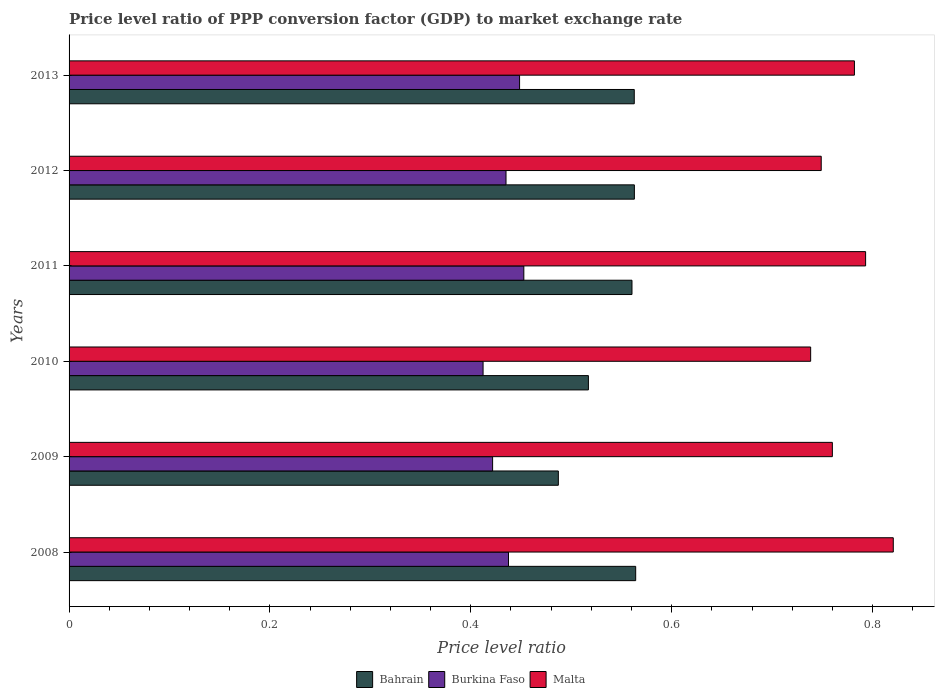How many groups of bars are there?
Ensure brevity in your answer.  6. Are the number of bars per tick equal to the number of legend labels?
Make the answer very short. Yes. What is the label of the 4th group of bars from the top?
Give a very brief answer. 2010. In how many cases, is the number of bars for a given year not equal to the number of legend labels?
Keep it short and to the point. 0. What is the price level ratio in Burkina Faso in 2012?
Your answer should be very brief. 0.44. Across all years, what is the maximum price level ratio in Bahrain?
Offer a very short reply. 0.56. Across all years, what is the minimum price level ratio in Bahrain?
Ensure brevity in your answer.  0.49. In which year was the price level ratio in Malta maximum?
Your response must be concise. 2008. In which year was the price level ratio in Bahrain minimum?
Make the answer very short. 2009. What is the total price level ratio in Malta in the graph?
Offer a very short reply. 4.64. What is the difference between the price level ratio in Bahrain in 2008 and that in 2009?
Offer a terse response. 0.08. What is the difference between the price level ratio in Malta in 2010 and the price level ratio in Burkina Faso in 2013?
Your answer should be compact. 0.29. What is the average price level ratio in Malta per year?
Give a very brief answer. 0.77. In the year 2010, what is the difference between the price level ratio in Malta and price level ratio in Bahrain?
Provide a succinct answer. 0.22. What is the ratio of the price level ratio in Bahrain in 2008 to that in 2010?
Offer a terse response. 1.09. Is the difference between the price level ratio in Malta in 2009 and 2012 greater than the difference between the price level ratio in Bahrain in 2009 and 2012?
Ensure brevity in your answer.  Yes. What is the difference between the highest and the second highest price level ratio in Malta?
Give a very brief answer. 0.03. What is the difference between the highest and the lowest price level ratio in Malta?
Offer a very short reply. 0.08. In how many years, is the price level ratio in Burkina Faso greater than the average price level ratio in Burkina Faso taken over all years?
Your answer should be very brief. 4. Is the sum of the price level ratio in Malta in 2008 and 2013 greater than the maximum price level ratio in Burkina Faso across all years?
Offer a terse response. Yes. What does the 3rd bar from the top in 2008 represents?
Offer a very short reply. Bahrain. What does the 2nd bar from the bottom in 2008 represents?
Provide a succinct answer. Burkina Faso. Are the values on the major ticks of X-axis written in scientific E-notation?
Offer a terse response. No. Where does the legend appear in the graph?
Provide a succinct answer. Bottom center. How are the legend labels stacked?
Ensure brevity in your answer.  Horizontal. What is the title of the graph?
Your response must be concise. Price level ratio of PPP conversion factor (GDP) to market exchange rate. What is the label or title of the X-axis?
Offer a very short reply. Price level ratio. What is the Price level ratio of Bahrain in 2008?
Your response must be concise. 0.56. What is the Price level ratio of Burkina Faso in 2008?
Keep it short and to the point. 0.44. What is the Price level ratio of Malta in 2008?
Your response must be concise. 0.82. What is the Price level ratio in Bahrain in 2009?
Offer a terse response. 0.49. What is the Price level ratio in Burkina Faso in 2009?
Give a very brief answer. 0.42. What is the Price level ratio in Malta in 2009?
Your answer should be very brief. 0.76. What is the Price level ratio in Bahrain in 2010?
Give a very brief answer. 0.52. What is the Price level ratio of Burkina Faso in 2010?
Make the answer very short. 0.41. What is the Price level ratio in Malta in 2010?
Keep it short and to the point. 0.74. What is the Price level ratio of Bahrain in 2011?
Your answer should be compact. 0.56. What is the Price level ratio in Burkina Faso in 2011?
Your response must be concise. 0.45. What is the Price level ratio of Malta in 2011?
Give a very brief answer. 0.79. What is the Price level ratio of Bahrain in 2012?
Offer a terse response. 0.56. What is the Price level ratio in Burkina Faso in 2012?
Offer a terse response. 0.44. What is the Price level ratio of Malta in 2012?
Provide a succinct answer. 0.75. What is the Price level ratio in Bahrain in 2013?
Your answer should be compact. 0.56. What is the Price level ratio of Burkina Faso in 2013?
Give a very brief answer. 0.45. What is the Price level ratio of Malta in 2013?
Your response must be concise. 0.78. Across all years, what is the maximum Price level ratio in Bahrain?
Your answer should be compact. 0.56. Across all years, what is the maximum Price level ratio of Burkina Faso?
Provide a succinct answer. 0.45. Across all years, what is the maximum Price level ratio of Malta?
Your response must be concise. 0.82. Across all years, what is the minimum Price level ratio of Bahrain?
Your answer should be very brief. 0.49. Across all years, what is the minimum Price level ratio of Burkina Faso?
Offer a terse response. 0.41. Across all years, what is the minimum Price level ratio of Malta?
Provide a succinct answer. 0.74. What is the total Price level ratio of Bahrain in the graph?
Your answer should be very brief. 3.25. What is the total Price level ratio of Burkina Faso in the graph?
Give a very brief answer. 2.61. What is the total Price level ratio of Malta in the graph?
Provide a short and direct response. 4.64. What is the difference between the Price level ratio in Bahrain in 2008 and that in 2009?
Your answer should be compact. 0.08. What is the difference between the Price level ratio of Burkina Faso in 2008 and that in 2009?
Your response must be concise. 0.02. What is the difference between the Price level ratio of Malta in 2008 and that in 2009?
Give a very brief answer. 0.06. What is the difference between the Price level ratio in Bahrain in 2008 and that in 2010?
Offer a terse response. 0.05. What is the difference between the Price level ratio of Burkina Faso in 2008 and that in 2010?
Offer a very short reply. 0.03. What is the difference between the Price level ratio of Malta in 2008 and that in 2010?
Give a very brief answer. 0.08. What is the difference between the Price level ratio in Bahrain in 2008 and that in 2011?
Ensure brevity in your answer.  0. What is the difference between the Price level ratio in Burkina Faso in 2008 and that in 2011?
Provide a short and direct response. -0.02. What is the difference between the Price level ratio of Malta in 2008 and that in 2011?
Provide a short and direct response. 0.03. What is the difference between the Price level ratio in Bahrain in 2008 and that in 2012?
Provide a succinct answer. 0. What is the difference between the Price level ratio in Burkina Faso in 2008 and that in 2012?
Your answer should be very brief. 0. What is the difference between the Price level ratio of Malta in 2008 and that in 2012?
Keep it short and to the point. 0.07. What is the difference between the Price level ratio of Bahrain in 2008 and that in 2013?
Provide a succinct answer. 0. What is the difference between the Price level ratio of Burkina Faso in 2008 and that in 2013?
Your answer should be compact. -0.01. What is the difference between the Price level ratio in Malta in 2008 and that in 2013?
Provide a succinct answer. 0.04. What is the difference between the Price level ratio of Bahrain in 2009 and that in 2010?
Your answer should be compact. -0.03. What is the difference between the Price level ratio of Burkina Faso in 2009 and that in 2010?
Provide a short and direct response. 0.01. What is the difference between the Price level ratio of Malta in 2009 and that in 2010?
Ensure brevity in your answer.  0.02. What is the difference between the Price level ratio of Bahrain in 2009 and that in 2011?
Provide a short and direct response. -0.07. What is the difference between the Price level ratio in Burkina Faso in 2009 and that in 2011?
Offer a very short reply. -0.03. What is the difference between the Price level ratio in Malta in 2009 and that in 2011?
Provide a succinct answer. -0.03. What is the difference between the Price level ratio in Bahrain in 2009 and that in 2012?
Give a very brief answer. -0.08. What is the difference between the Price level ratio of Burkina Faso in 2009 and that in 2012?
Your answer should be compact. -0.01. What is the difference between the Price level ratio of Malta in 2009 and that in 2012?
Your answer should be compact. 0.01. What is the difference between the Price level ratio in Bahrain in 2009 and that in 2013?
Provide a short and direct response. -0.08. What is the difference between the Price level ratio in Burkina Faso in 2009 and that in 2013?
Your response must be concise. -0.03. What is the difference between the Price level ratio of Malta in 2009 and that in 2013?
Your answer should be compact. -0.02. What is the difference between the Price level ratio of Bahrain in 2010 and that in 2011?
Give a very brief answer. -0.04. What is the difference between the Price level ratio of Burkina Faso in 2010 and that in 2011?
Make the answer very short. -0.04. What is the difference between the Price level ratio in Malta in 2010 and that in 2011?
Keep it short and to the point. -0.05. What is the difference between the Price level ratio of Bahrain in 2010 and that in 2012?
Offer a very short reply. -0.05. What is the difference between the Price level ratio of Burkina Faso in 2010 and that in 2012?
Your response must be concise. -0.02. What is the difference between the Price level ratio in Malta in 2010 and that in 2012?
Make the answer very short. -0.01. What is the difference between the Price level ratio in Bahrain in 2010 and that in 2013?
Ensure brevity in your answer.  -0.05. What is the difference between the Price level ratio of Burkina Faso in 2010 and that in 2013?
Offer a terse response. -0.04. What is the difference between the Price level ratio of Malta in 2010 and that in 2013?
Give a very brief answer. -0.04. What is the difference between the Price level ratio of Bahrain in 2011 and that in 2012?
Provide a short and direct response. -0. What is the difference between the Price level ratio of Burkina Faso in 2011 and that in 2012?
Provide a short and direct response. 0.02. What is the difference between the Price level ratio of Malta in 2011 and that in 2012?
Give a very brief answer. 0.04. What is the difference between the Price level ratio in Bahrain in 2011 and that in 2013?
Your answer should be compact. -0. What is the difference between the Price level ratio of Burkina Faso in 2011 and that in 2013?
Your answer should be compact. 0. What is the difference between the Price level ratio in Malta in 2011 and that in 2013?
Offer a terse response. 0.01. What is the difference between the Price level ratio in Bahrain in 2012 and that in 2013?
Your answer should be very brief. 0. What is the difference between the Price level ratio in Burkina Faso in 2012 and that in 2013?
Provide a short and direct response. -0.01. What is the difference between the Price level ratio of Malta in 2012 and that in 2013?
Ensure brevity in your answer.  -0.03. What is the difference between the Price level ratio of Bahrain in 2008 and the Price level ratio of Burkina Faso in 2009?
Give a very brief answer. 0.14. What is the difference between the Price level ratio in Bahrain in 2008 and the Price level ratio in Malta in 2009?
Offer a very short reply. -0.2. What is the difference between the Price level ratio in Burkina Faso in 2008 and the Price level ratio in Malta in 2009?
Keep it short and to the point. -0.32. What is the difference between the Price level ratio of Bahrain in 2008 and the Price level ratio of Burkina Faso in 2010?
Provide a succinct answer. 0.15. What is the difference between the Price level ratio in Bahrain in 2008 and the Price level ratio in Malta in 2010?
Offer a very short reply. -0.17. What is the difference between the Price level ratio of Burkina Faso in 2008 and the Price level ratio of Malta in 2010?
Give a very brief answer. -0.3. What is the difference between the Price level ratio of Bahrain in 2008 and the Price level ratio of Burkina Faso in 2011?
Keep it short and to the point. 0.11. What is the difference between the Price level ratio in Bahrain in 2008 and the Price level ratio in Malta in 2011?
Ensure brevity in your answer.  -0.23. What is the difference between the Price level ratio in Burkina Faso in 2008 and the Price level ratio in Malta in 2011?
Ensure brevity in your answer.  -0.36. What is the difference between the Price level ratio of Bahrain in 2008 and the Price level ratio of Burkina Faso in 2012?
Provide a succinct answer. 0.13. What is the difference between the Price level ratio in Bahrain in 2008 and the Price level ratio in Malta in 2012?
Ensure brevity in your answer.  -0.18. What is the difference between the Price level ratio of Burkina Faso in 2008 and the Price level ratio of Malta in 2012?
Make the answer very short. -0.31. What is the difference between the Price level ratio in Bahrain in 2008 and the Price level ratio in Burkina Faso in 2013?
Keep it short and to the point. 0.12. What is the difference between the Price level ratio of Bahrain in 2008 and the Price level ratio of Malta in 2013?
Offer a terse response. -0.22. What is the difference between the Price level ratio in Burkina Faso in 2008 and the Price level ratio in Malta in 2013?
Your response must be concise. -0.34. What is the difference between the Price level ratio in Bahrain in 2009 and the Price level ratio in Burkina Faso in 2010?
Your answer should be very brief. 0.07. What is the difference between the Price level ratio in Bahrain in 2009 and the Price level ratio in Malta in 2010?
Ensure brevity in your answer.  -0.25. What is the difference between the Price level ratio in Burkina Faso in 2009 and the Price level ratio in Malta in 2010?
Offer a very short reply. -0.32. What is the difference between the Price level ratio in Bahrain in 2009 and the Price level ratio in Burkina Faso in 2011?
Provide a succinct answer. 0.03. What is the difference between the Price level ratio in Bahrain in 2009 and the Price level ratio in Malta in 2011?
Offer a terse response. -0.31. What is the difference between the Price level ratio in Burkina Faso in 2009 and the Price level ratio in Malta in 2011?
Provide a short and direct response. -0.37. What is the difference between the Price level ratio of Bahrain in 2009 and the Price level ratio of Burkina Faso in 2012?
Offer a very short reply. 0.05. What is the difference between the Price level ratio in Bahrain in 2009 and the Price level ratio in Malta in 2012?
Your answer should be very brief. -0.26. What is the difference between the Price level ratio in Burkina Faso in 2009 and the Price level ratio in Malta in 2012?
Give a very brief answer. -0.33. What is the difference between the Price level ratio in Bahrain in 2009 and the Price level ratio in Burkina Faso in 2013?
Your answer should be compact. 0.04. What is the difference between the Price level ratio of Bahrain in 2009 and the Price level ratio of Malta in 2013?
Provide a succinct answer. -0.29. What is the difference between the Price level ratio in Burkina Faso in 2009 and the Price level ratio in Malta in 2013?
Your response must be concise. -0.36. What is the difference between the Price level ratio in Bahrain in 2010 and the Price level ratio in Burkina Faso in 2011?
Your response must be concise. 0.06. What is the difference between the Price level ratio in Bahrain in 2010 and the Price level ratio in Malta in 2011?
Provide a succinct answer. -0.28. What is the difference between the Price level ratio in Burkina Faso in 2010 and the Price level ratio in Malta in 2011?
Ensure brevity in your answer.  -0.38. What is the difference between the Price level ratio in Bahrain in 2010 and the Price level ratio in Burkina Faso in 2012?
Provide a short and direct response. 0.08. What is the difference between the Price level ratio of Bahrain in 2010 and the Price level ratio of Malta in 2012?
Your answer should be very brief. -0.23. What is the difference between the Price level ratio of Burkina Faso in 2010 and the Price level ratio of Malta in 2012?
Offer a terse response. -0.34. What is the difference between the Price level ratio in Bahrain in 2010 and the Price level ratio in Burkina Faso in 2013?
Provide a short and direct response. 0.07. What is the difference between the Price level ratio of Bahrain in 2010 and the Price level ratio of Malta in 2013?
Keep it short and to the point. -0.26. What is the difference between the Price level ratio in Burkina Faso in 2010 and the Price level ratio in Malta in 2013?
Your answer should be compact. -0.37. What is the difference between the Price level ratio of Bahrain in 2011 and the Price level ratio of Burkina Faso in 2012?
Your answer should be compact. 0.13. What is the difference between the Price level ratio of Bahrain in 2011 and the Price level ratio of Malta in 2012?
Your response must be concise. -0.19. What is the difference between the Price level ratio in Burkina Faso in 2011 and the Price level ratio in Malta in 2012?
Make the answer very short. -0.3. What is the difference between the Price level ratio in Bahrain in 2011 and the Price level ratio in Burkina Faso in 2013?
Give a very brief answer. 0.11. What is the difference between the Price level ratio of Bahrain in 2011 and the Price level ratio of Malta in 2013?
Keep it short and to the point. -0.22. What is the difference between the Price level ratio in Burkina Faso in 2011 and the Price level ratio in Malta in 2013?
Offer a terse response. -0.33. What is the difference between the Price level ratio of Bahrain in 2012 and the Price level ratio of Burkina Faso in 2013?
Give a very brief answer. 0.11. What is the difference between the Price level ratio of Bahrain in 2012 and the Price level ratio of Malta in 2013?
Provide a succinct answer. -0.22. What is the difference between the Price level ratio in Burkina Faso in 2012 and the Price level ratio in Malta in 2013?
Offer a very short reply. -0.35. What is the average Price level ratio in Bahrain per year?
Your answer should be very brief. 0.54. What is the average Price level ratio of Burkina Faso per year?
Keep it short and to the point. 0.43. What is the average Price level ratio in Malta per year?
Your answer should be compact. 0.77. In the year 2008, what is the difference between the Price level ratio in Bahrain and Price level ratio in Burkina Faso?
Provide a short and direct response. 0.13. In the year 2008, what is the difference between the Price level ratio in Bahrain and Price level ratio in Malta?
Provide a short and direct response. -0.26. In the year 2008, what is the difference between the Price level ratio of Burkina Faso and Price level ratio of Malta?
Provide a short and direct response. -0.38. In the year 2009, what is the difference between the Price level ratio of Bahrain and Price level ratio of Burkina Faso?
Offer a terse response. 0.07. In the year 2009, what is the difference between the Price level ratio of Bahrain and Price level ratio of Malta?
Give a very brief answer. -0.27. In the year 2009, what is the difference between the Price level ratio in Burkina Faso and Price level ratio in Malta?
Give a very brief answer. -0.34. In the year 2010, what is the difference between the Price level ratio of Bahrain and Price level ratio of Burkina Faso?
Make the answer very short. 0.1. In the year 2010, what is the difference between the Price level ratio of Bahrain and Price level ratio of Malta?
Offer a terse response. -0.22. In the year 2010, what is the difference between the Price level ratio in Burkina Faso and Price level ratio in Malta?
Provide a short and direct response. -0.33. In the year 2011, what is the difference between the Price level ratio of Bahrain and Price level ratio of Burkina Faso?
Provide a succinct answer. 0.11. In the year 2011, what is the difference between the Price level ratio in Bahrain and Price level ratio in Malta?
Offer a terse response. -0.23. In the year 2011, what is the difference between the Price level ratio in Burkina Faso and Price level ratio in Malta?
Provide a short and direct response. -0.34. In the year 2012, what is the difference between the Price level ratio of Bahrain and Price level ratio of Burkina Faso?
Provide a short and direct response. 0.13. In the year 2012, what is the difference between the Price level ratio of Bahrain and Price level ratio of Malta?
Provide a succinct answer. -0.19. In the year 2012, what is the difference between the Price level ratio of Burkina Faso and Price level ratio of Malta?
Keep it short and to the point. -0.31. In the year 2013, what is the difference between the Price level ratio of Bahrain and Price level ratio of Burkina Faso?
Offer a terse response. 0.11. In the year 2013, what is the difference between the Price level ratio of Bahrain and Price level ratio of Malta?
Offer a very short reply. -0.22. In the year 2013, what is the difference between the Price level ratio of Burkina Faso and Price level ratio of Malta?
Your response must be concise. -0.33. What is the ratio of the Price level ratio in Bahrain in 2008 to that in 2009?
Your answer should be very brief. 1.16. What is the ratio of the Price level ratio in Burkina Faso in 2008 to that in 2009?
Your answer should be very brief. 1.04. What is the ratio of the Price level ratio in Malta in 2008 to that in 2009?
Your answer should be compact. 1.08. What is the ratio of the Price level ratio in Bahrain in 2008 to that in 2010?
Keep it short and to the point. 1.09. What is the ratio of the Price level ratio of Burkina Faso in 2008 to that in 2010?
Keep it short and to the point. 1.06. What is the ratio of the Price level ratio of Malta in 2008 to that in 2010?
Make the answer very short. 1.11. What is the ratio of the Price level ratio of Bahrain in 2008 to that in 2011?
Make the answer very short. 1.01. What is the ratio of the Price level ratio of Burkina Faso in 2008 to that in 2011?
Offer a very short reply. 0.97. What is the ratio of the Price level ratio in Malta in 2008 to that in 2011?
Make the answer very short. 1.03. What is the ratio of the Price level ratio in Bahrain in 2008 to that in 2012?
Provide a succinct answer. 1. What is the ratio of the Price level ratio of Malta in 2008 to that in 2012?
Offer a very short reply. 1.1. What is the ratio of the Price level ratio in Burkina Faso in 2008 to that in 2013?
Keep it short and to the point. 0.98. What is the ratio of the Price level ratio in Malta in 2008 to that in 2013?
Your response must be concise. 1.05. What is the ratio of the Price level ratio of Bahrain in 2009 to that in 2010?
Keep it short and to the point. 0.94. What is the ratio of the Price level ratio of Burkina Faso in 2009 to that in 2010?
Provide a short and direct response. 1.02. What is the ratio of the Price level ratio of Malta in 2009 to that in 2010?
Your response must be concise. 1.03. What is the ratio of the Price level ratio of Bahrain in 2009 to that in 2011?
Offer a very short reply. 0.87. What is the ratio of the Price level ratio in Burkina Faso in 2009 to that in 2011?
Ensure brevity in your answer.  0.93. What is the ratio of the Price level ratio in Bahrain in 2009 to that in 2012?
Offer a very short reply. 0.87. What is the ratio of the Price level ratio in Burkina Faso in 2009 to that in 2012?
Ensure brevity in your answer.  0.97. What is the ratio of the Price level ratio of Malta in 2009 to that in 2012?
Your answer should be very brief. 1.01. What is the ratio of the Price level ratio of Bahrain in 2009 to that in 2013?
Ensure brevity in your answer.  0.87. What is the ratio of the Price level ratio of Burkina Faso in 2009 to that in 2013?
Give a very brief answer. 0.94. What is the ratio of the Price level ratio in Malta in 2009 to that in 2013?
Your answer should be very brief. 0.97. What is the ratio of the Price level ratio in Bahrain in 2010 to that in 2011?
Your answer should be compact. 0.92. What is the ratio of the Price level ratio in Burkina Faso in 2010 to that in 2011?
Your answer should be very brief. 0.91. What is the ratio of the Price level ratio in Malta in 2010 to that in 2011?
Your answer should be very brief. 0.93. What is the ratio of the Price level ratio of Bahrain in 2010 to that in 2012?
Provide a succinct answer. 0.92. What is the ratio of the Price level ratio of Burkina Faso in 2010 to that in 2012?
Your answer should be compact. 0.95. What is the ratio of the Price level ratio in Malta in 2010 to that in 2012?
Ensure brevity in your answer.  0.99. What is the ratio of the Price level ratio in Bahrain in 2010 to that in 2013?
Ensure brevity in your answer.  0.92. What is the ratio of the Price level ratio of Burkina Faso in 2010 to that in 2013?
Your answer should be very brief. 0.92. What is the ratio of the Price level ratio in Malta in 2010 to that in 2013?
Offer a terse response. 0.94. What is the ratio of the Price level ratio in Bahrain in 2011 to that in 2012?
Your response must be concise. 1. What is the ratio of the Price level ratio in Burkina Faso in 2011 to that in 2012?
Give a very brief answer. 1.04. What is the ratio of the Price level ratio in Malta in 2011 to that in 2012?
Ensure brevity in your answer.  1.06. What is the ratio of the Price level ratio of Burkina Faso in 2011 to that in 2013?
Provide a succinct answer. 1.01. What is the ratio of the Price level ratio in Malta in 2011 to that in 2013?
Offer a very short reply. 1.01. What is the ratio of the Price level ratio in Bahrain in 2012 to that in 2013?
Provide a succinct answer. 1. What is the ratio of the Price level ratio in Burkina Faso in 2012 to that in 2013?
Your answer should be very brief. 0.97. What is the ratio of the Price level ratio in Malta in 2012 to that in 2013?
Provide a succinct answer. 0.96. What is the difference between the highest and the second highest Price level ratio in Bahrain?
Your answer should be compact. 0. What is the difference between the highest and the second highest Price level ratio in Burkina Faso?
Your response must be concise. 0. What is the difference between the highest and the second highest Price level ratio of Malta?
Your response must be concise. 0.03. What is the difference between the highest and the lowest Price level ratio in Bahrain?
Your answer should be very brief. 0.08. What is the difference between the highest and the lowest Price level ratio of Burkina Faso?
Provide a succinct answer. 0.04. What is the difference between the highest and the lowest Price level ratio of Malta?
Ensure brevity in your answer.  0.08. 